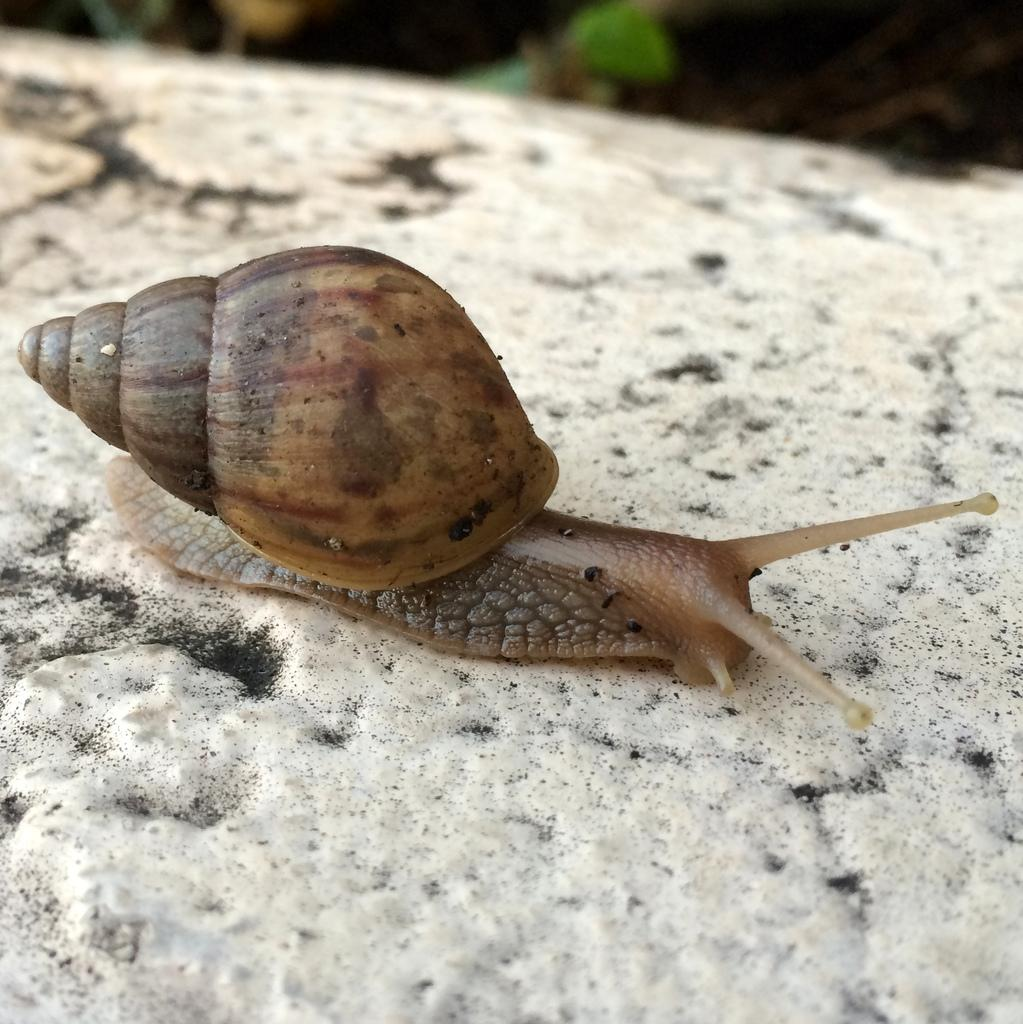What type of animal is in the image? There is a snail in the image. What is the snail resting on or attached to? The snail is on a surface. What type of waves can be seen crashing against the prison in the image? There is no prison or waves present in the image; it features a snail on a surface. 